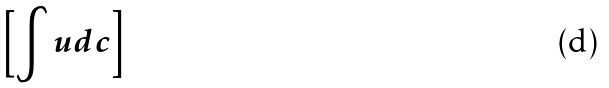<formula> <loc_0><loc_0><loc_500><loc_500>\left [ \int u d c \right ]</formula> 